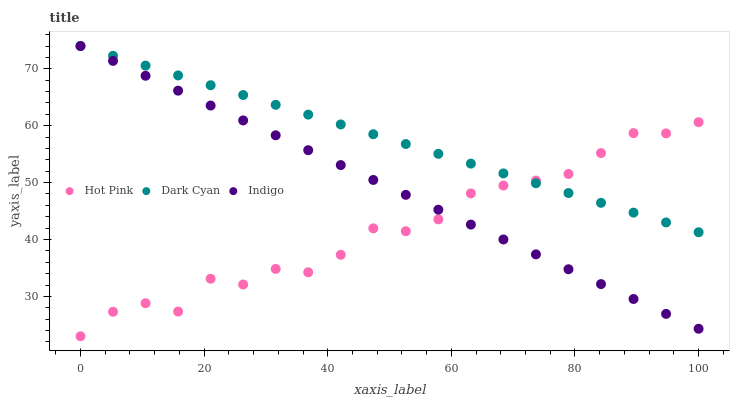Does Hot Pink have the minimum area under the curve?
Answer yes or no. Yes. Does Dark Cyan have the maximum area under the curve?
Answer yes or no. Yes. Does Indigo have the minimum area under the curve?
Answer yes or no. No. Does Indigo have the maximum area under the curve?
Answer yes or no. No. Is Indigo the smoothest?
Answer yes or no. Yes. Is Hot Pink the roughest?
Answer yes or no. Yes. Is Hot Pink the smoothest?
Answer yes or no. No. Is Indigo the roughest?
Answer yes or no. No. Does Hot Pink have the lowest value?
Answer yes or no. Yes. Does Indigo have the lowest value?
Answer yes or no. No. Does Indigo have the highest value?
Answer yes or no. Yes. Does Hot Pink have the highest value?
Answer yes or no. No. Does Hot Pink intersect Indigo?
Answer yes or no. Yes. Is Hot Pink less than Indigo?
Answer yes or no. No. Is Hot Pink greater than Indigo?
Answer yes or no. No. 